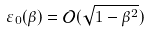Convert formula to latex. <formula><loc_0><loc_0><loc_500><loc_500>\varepsilon _ { 0 } ( \beta ) = \mathcal { O } ( \sqrt { 1 - \beta ^ { 2 } } )</formula> 